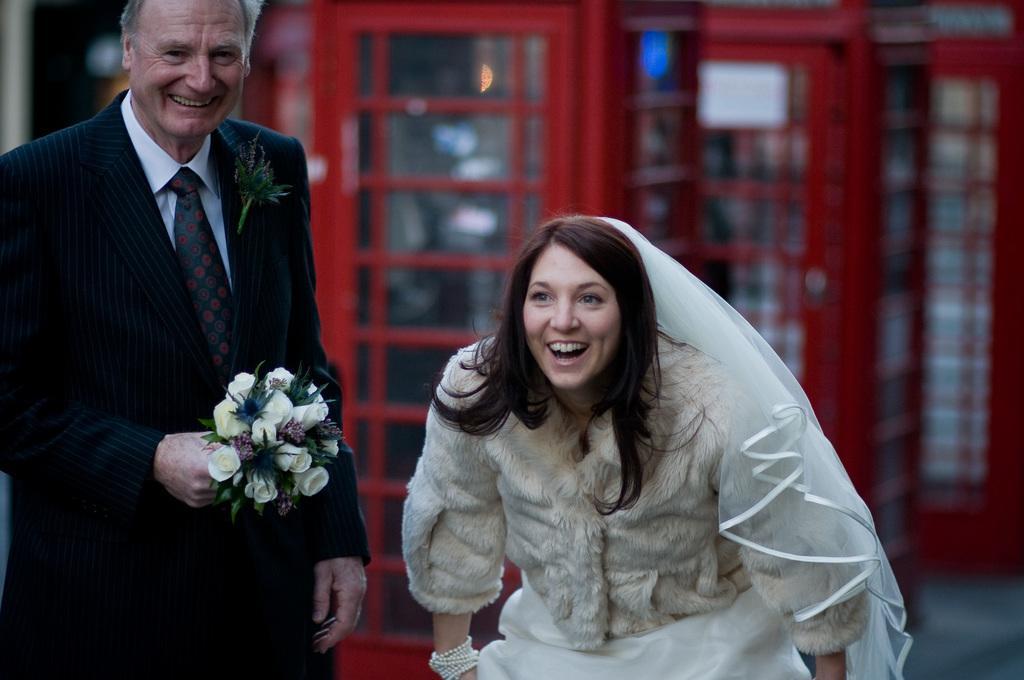Describe this image in one or two sentences. Here I can see a woman standing and smiling. On the left side a man wearing a black color suit, holding some flowers in the hand, standing and smiling. In the background, I can see few cabins. 